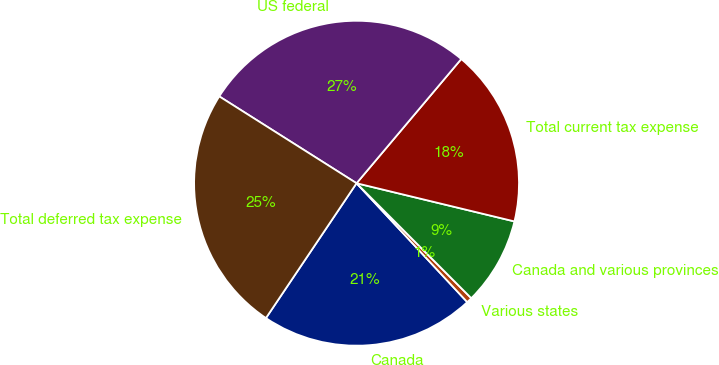<chart> <loc_0><loc_0><loc_500><loc_500><pie_chart><fcel>Canada<fcel>Various states<fcel>Canada and various provinces<fcel>Total current tax expense<fcel>US federal<fcel>Total deferred tax expense<nl><fcel>21.35%<fcel>0.55%<fcel>8.74%<fcel>17.63%<fcel>27.17%<fcel>24.56%<nl></chart> 